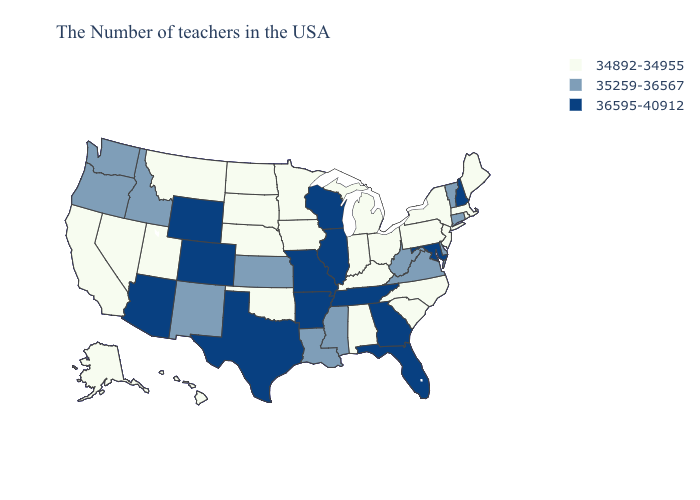Name the states that have a value in the range 35259-36567?
Write a very short answer. Vermont, Connecticut, Delaware, Virginia, West Virginia, Mississippi, Louisiana, Kansas, New Mexico, Idaho, Washington, Oregon. Does Virginia have a higher value than Illinois?
Quick response, please. No. What is the lowest value in the South?
Keep it brief. 34892-34955. What is the lowest value in the USA?
Be succinct. 34892-34955. What is the lowest value in the USA?
Short answer required. 34892-34955. Among the states that border Ohio , does West Virginia have the lowest value?
Keep it brief. No. What is the value of New York?
Answer briefly. 34892-34955. Does New Hampshire have the lowest value in the Northeast?
Short answer required. No. How many symbols are there in the legend?
Give a very brief answer. 3. Name the states that have a value in the range 34892-34955?
Keep it brief. Maine, Massachusetts, Rhode Island, New York, New Jersey, Pennsylvania, North Carolina, South Carolina, Ohio, Michigan, Kentucky, Indiana, Alabama, Minnesota, Iowa, Nebraska, Oklahoma, South Dakota, North Dakota, Utah, Montana, Nevada, California, Alaska, Hawaii. What is the value of Hawaii?
Answer briefly. 34892-34955. Name the states that have a value in the range 34892-34955?
Answer briefly. Maine, Massachusetts, Rhode Island, New York, New Jersey, Pennsylvania, North Carolina, South Carolina, Ohio, Michigan, Kentucky, Indiana, Alabama, Minnesota, Iowa, Nebraska, Oklahoma, South Dakota, North Dakota, Utah, Montana, Nevada, California, Alaska, Hawaii. Does the first symbol in the legend represent the smallest category?
Keep it brief. Yes. Does Texas have the lowest value in the USA?
Keep it brief. No. Name the states that have a value in the range 35259-36567?
Be succinct. Vermont, Connecticut, Delaware, Virginia, West Virginia, Mississippi, Louisiana, Kansas, New Mexico, Idaho, Washington, Oregon. 